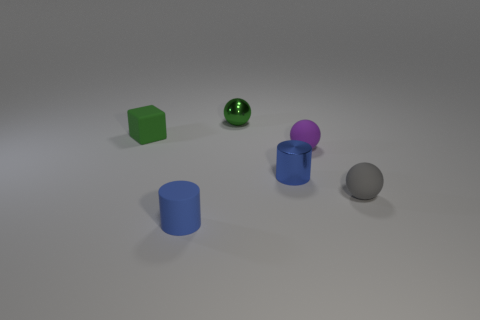What number of objects are small objects in front of the blue metallic cylinder or small shiny cylinders? In this tranquil scene, there are exactly three small objects that are either positioned in front of the captivating blue metallic cylinder or share its characteristic of being small shiny cylinders. These objects include a diminutive green cube that adds a touch of vivid color to the setting, a glinting, reflective sphere whose surface catches light in an entrancing manner, and a small shiny cylinder whose sleek surface is a miniature echo of the larger blue cylinder's sheen. 